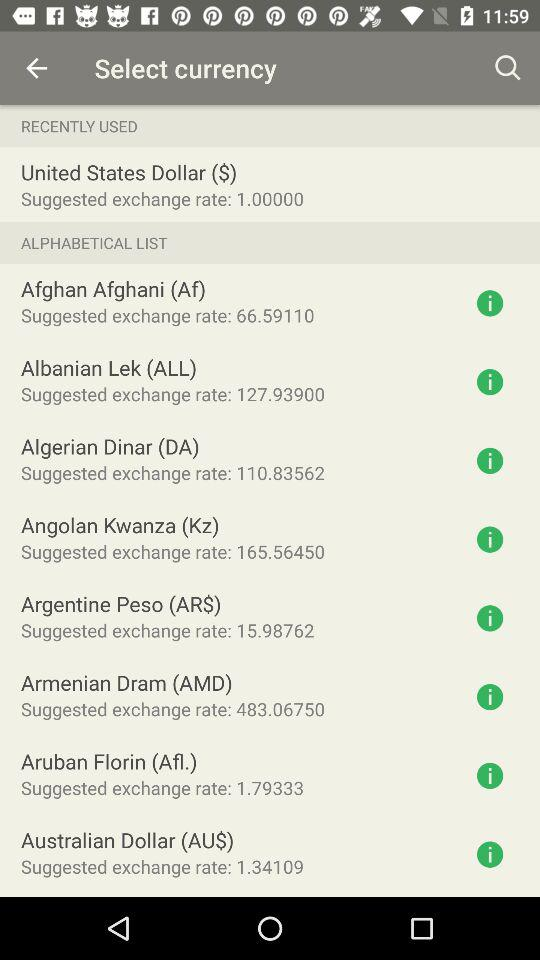What is the suggested exchange rate for the United States dollar? The suggested exchange rate for the United States dollar is 1. 